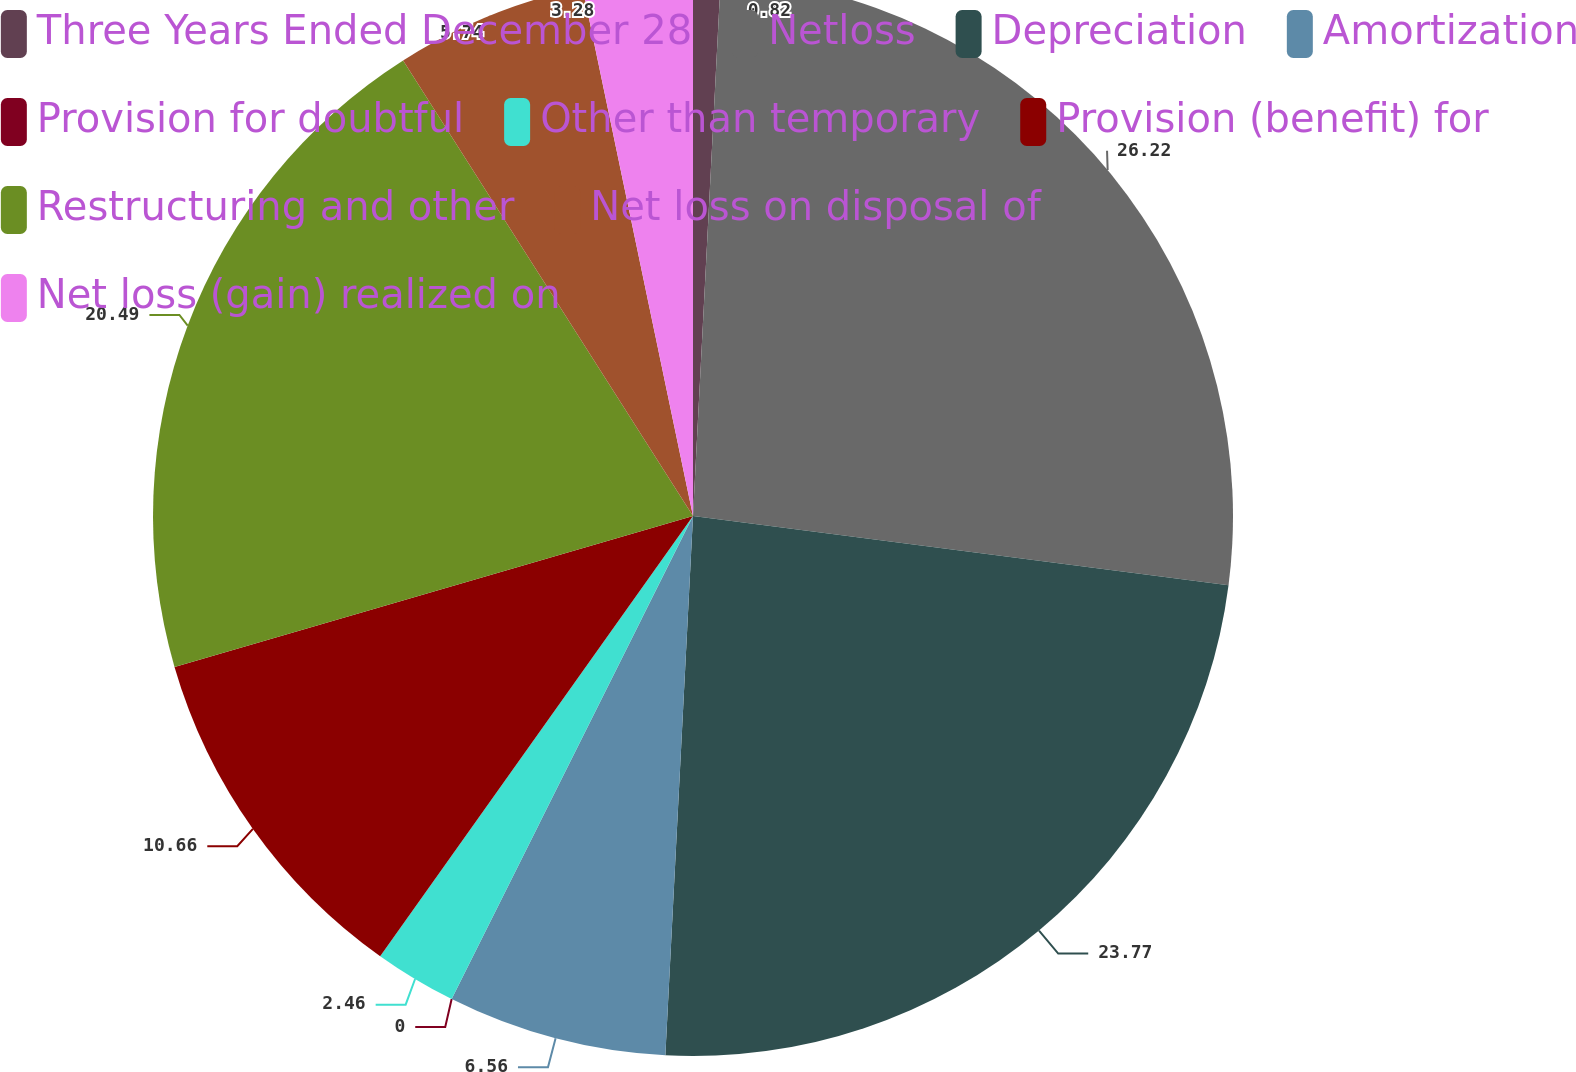<chart> <loc_0><loc_0><loc_500><loc_500><pie_chart><fcel>Three Years Ended December 28<fcel>Netloss<fcel>Depreciation<fcel>Amortization<fcel>Provision for doubtful<fcel>Other than temporary<fcel>Provision (benefit) for<fcel>Restructuring and other<fcel>Net loss on disposal of<fcel>Net loss (gain) realized on<nl><fcel>0.82%<fcel>26.23%<fcel>23.77%<fcel>6.56%<fcel>0.0%<fcel>2.46%<fcel>10.66%<fcel>20.49%<fcel>5.74%<fcel>3.28%<nl></chart> 